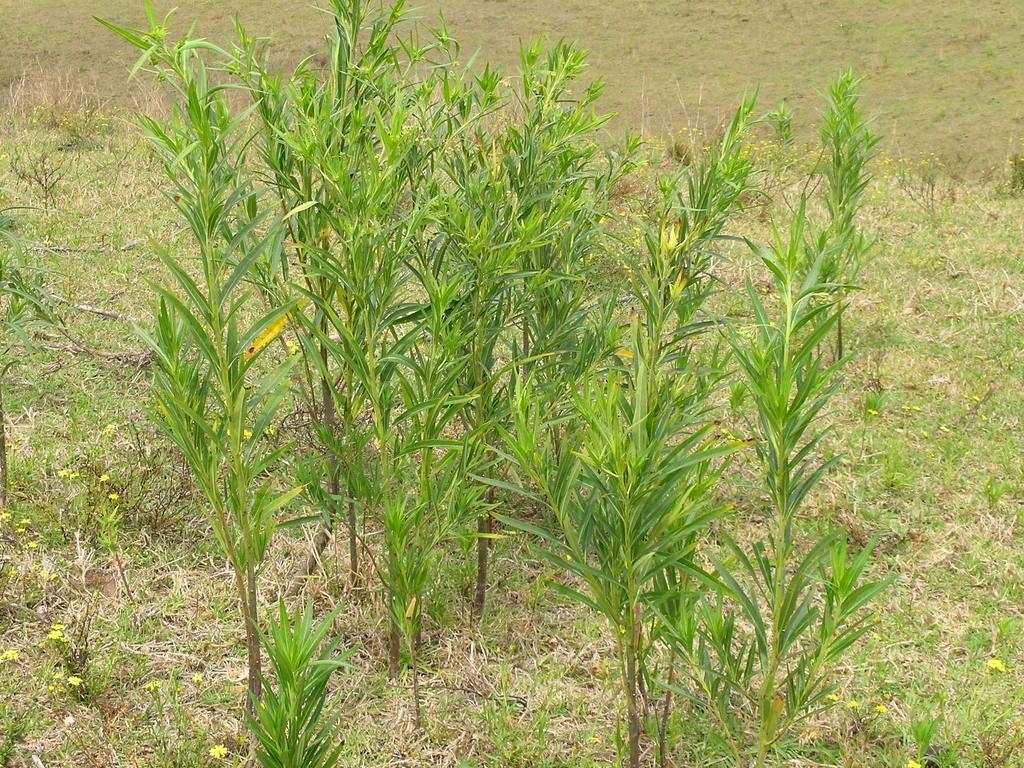How would you summarize this image in a sentence or two? In this picture we can see some plants in the front, at the bottom there is some grass and flowers. 